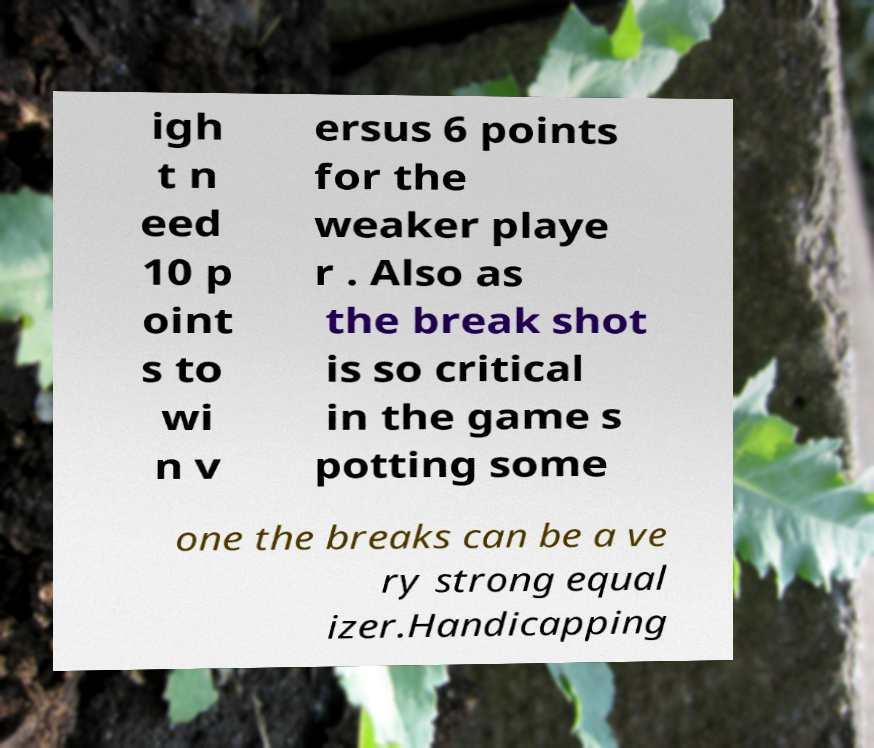For documentation purposes, I need the text within this image transcribed. Could you provide that? igh t n eed 10 p oint s to wi n v ersus 6 points for the weaker playe r . Also as the break shot is so critical in the game s potting some one the breaks can be a ve ry strong equal izer.Handicapping 